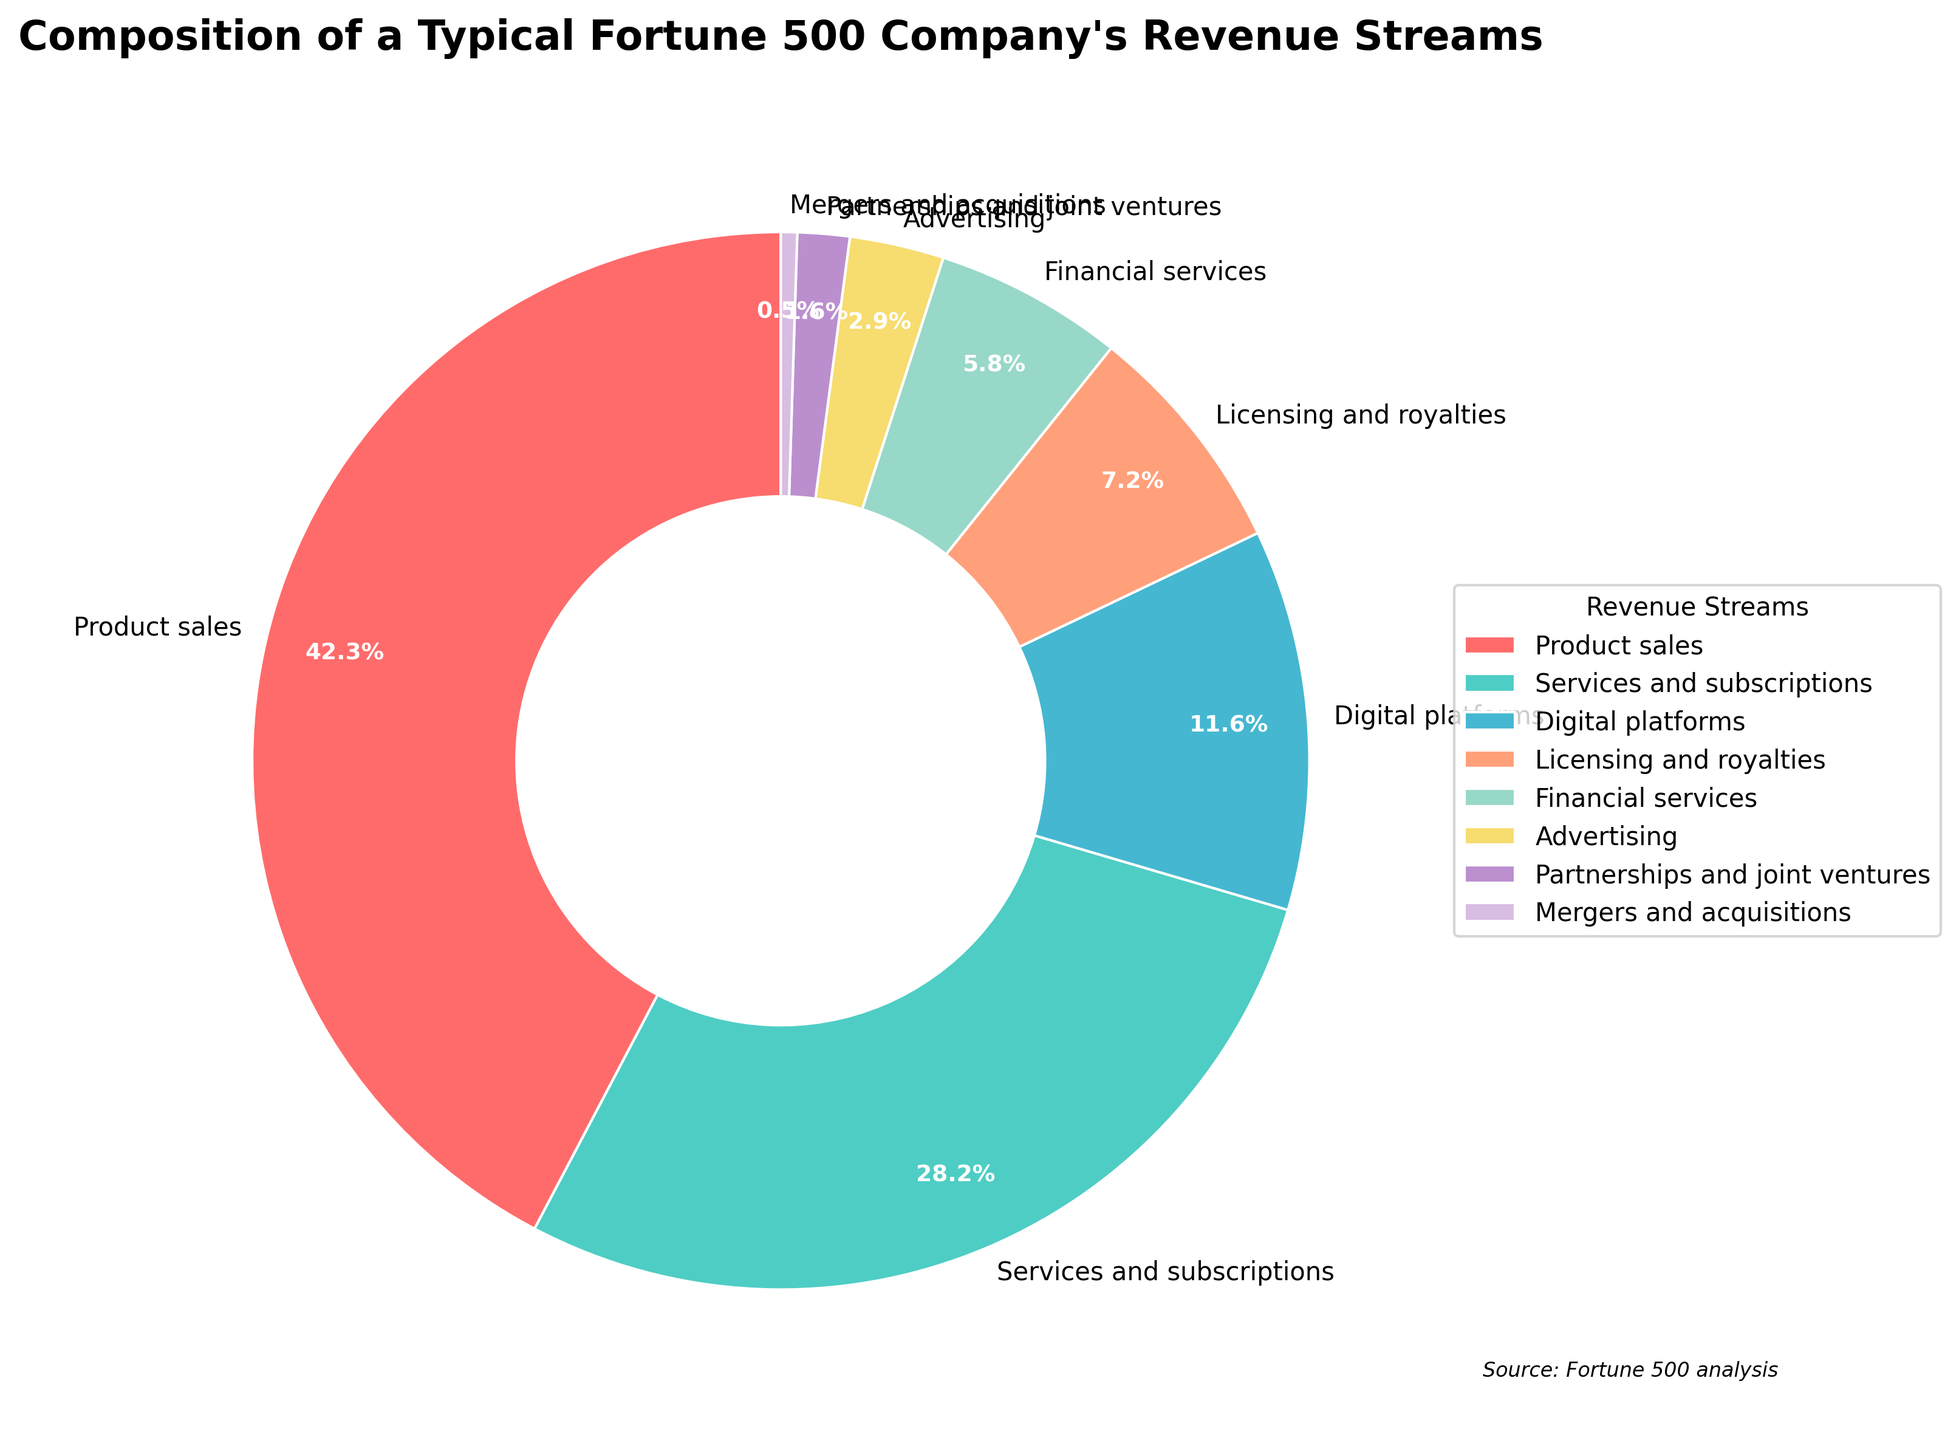What's the total percentage of revenue from services and subscriptions, and financial services? First, identify the percentage of revenue from services and subscriptions (28.3%) and financial services (5.8%). Then, sum these percentages: 28.3 + 5.8 = 34.1
Answer: 34.1 Compare the revenue percentages from product sales and from digital platforms. Which is larger, and by how much? The percentage from product sales is 42.5%, and from digital platforms, it’s 11.7%. Subtract the smaller percentage from the larger one: 42.5 - 11.7 = 30.8. Product sales is larger by 30.8 percentage points.
Answer: Product sales is larger by 30.8 What is the combined revenue percentage for partnerships and joint ventures, and mergers and acquisitions? The percentage from partnerships and joint ventures is 1.6%, and from mergers and acquisitions, it’s 0.5%. Add these two percentages: 1.6 + 0.5 = 2.1
Answer: 2.1 How does the visual representation of advertising compare in size to financial services? Advertising is represented by a smaller slice compared to financial services. Visually, the advertising slice occupies less area than the financial services slice, corresponding to their respective percentages (2.9% for advertising and 5.8% for financial services).
Answer: Financial services slice is larger Which revenue stream has the smallest percentage, and what is that percentage? By examining the pie chart, the smallest slice corresponds to mergers and acquisitions, which has the smallest percentage of 0.5%.
Answer: Mergers and acquisitions, 0.5% Calculate the combined percentage of product sales, services and subscriptions, and digital platforms. The percentages for product sales, services and subscriptions, and digital platforms are 42.5%, 28.3%, and 11.7%, respectively. Sum these values: 42.5 + 28.3 + 11.7 = 82.5
Answer: 82.5 Which revenue stream contributes more to the total revenue, licensing and royalties or advertising, and what is the difference? Licensing and royalties contribute 7.2% to the total revenue, whereas advertising contributes 2.9%. Subtract the smaller percentage from the larger one: 7.2 - 2.9 = 4.3. Licensing and royalties contribute more by 4.3 percentage points.
Answer: Licensing and royalties by 4.3 Determine the average percentage of revenue from all the streams combined. Add all the percentages: 42.5 + 28.3 + 11.7 + 7.2 + 5.8 + 2.9 + 1.6 + 0.5 = 100.5. Divide by the number of streams (8) to get the average: 100.5 / 8 = 12.5625
Answer: 12.56 Which two revenue streams together make up just over 50% of the total revenue? Identify the two largest percentages from the pie chart: product sales (42.5%) and services and subscriptions (28.3%). Sum these: 42.5 + 28.3 = 70.8, which is well over 50%. Now consider other combinations where the total is close to 50%. The best fit would be the largest stream (product sales) and the second or third largest, which is services and subscriptions or digital platforms. Since 42.5 + 11.7 is only 54.2%, not over 50%, the fit would be services and subscriptions and financial services: 28.3 + 11.7 = 40. Further combinations will show that product sales alone is enough to exceed this threshold.
Answer: Product sales alone, 42.5 